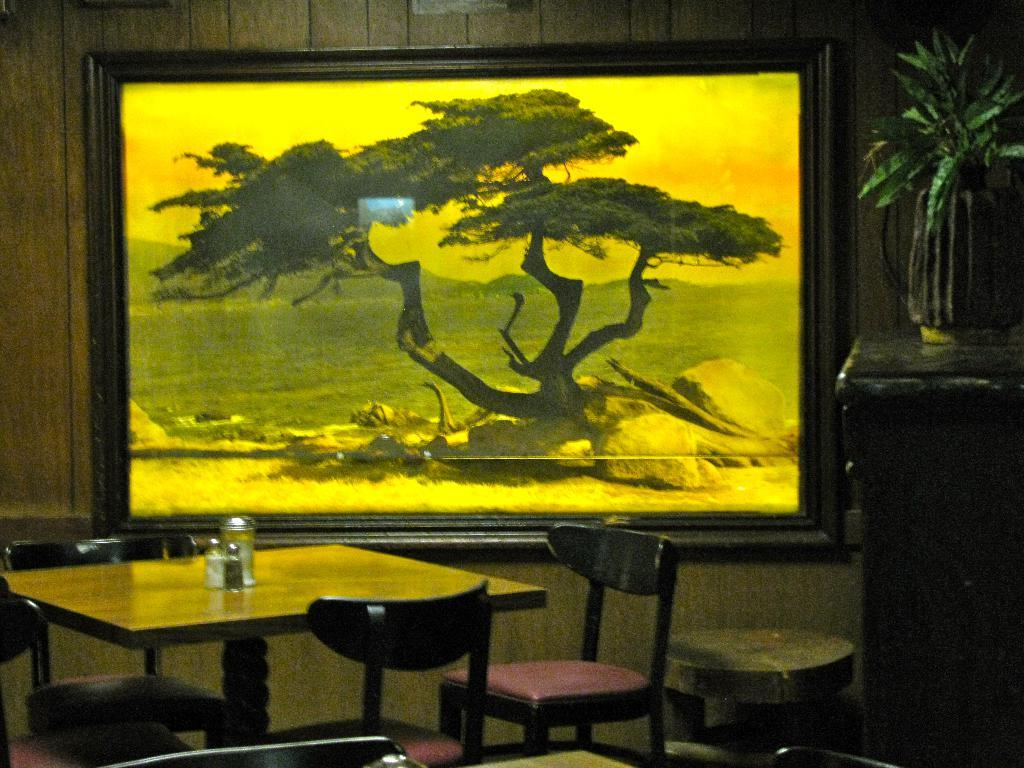What type of furniture is present in the image? There is a table and chairs in the image. What other object can be seen besides the furniture? There is a board in the image. How many people are in the crowd surrounding the table in the image? There is no crowd present in the image; it only features a table, board, and chairs. What type of fang can be seen on the table in the image? There is no fang present in the image; it only features a table, board, and chairs. 